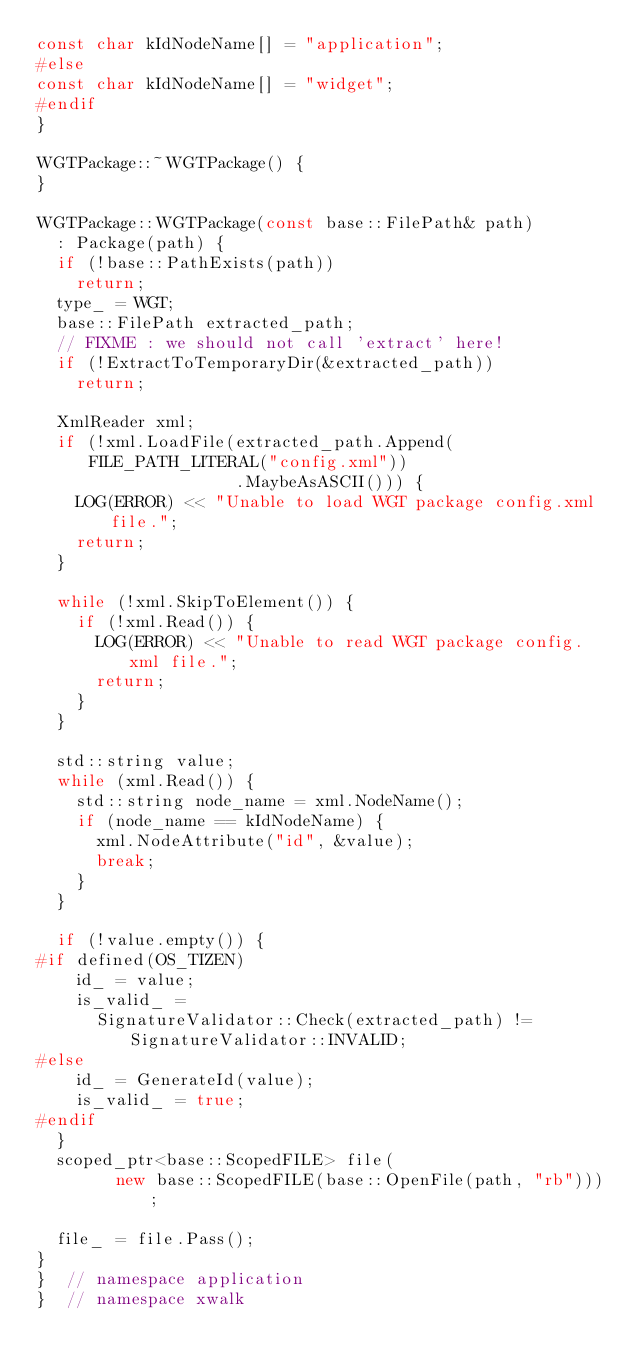Convert code to text. <code><loc_0><loc_0><loc_500><loc_500><_C++_>const char kIdNodeName[] = "application";
#else
const char kIdNodeName[] = "widget";
#endif
}

WGTPackage::~WGTPackage() {
}

WGTPackage::WGTPackage(const base::FilePath& path)
  : Package(path) {
  if (!base::PathExists(path))
    return;
  type_ = WGT;
  base::FilePath extracted_path;
  // FIXME : we should not call 'extract' here!
  if (!ExtractToTemporaryDir(&extracted_path))
    return;

  XmlReader xml;
  if (!xml.LoadFile(extracted_path.Append(FILE_PATH_LITERAL("config.xml"))
                    .MaybeAsASCII())) {
    LOG(ERROR) << "Unable to load WGT package config.xml file.";
    return;
  }

  while (!xml.SkipToElement()) {
    if (!xml.Read()) {
      LOG(ERROR) << "Unable to read WGT package config.xml file.";
      return;
    }
  }

  std::string value;
  while (xml.Read()) {
    std::string node_name = xml.NodeName();
    if (node_name == kIdNodeName) {
      xml.NodeAttribute("id", &value);
      break;
    }
  }

  if (!value.empty()) {
#if defined(OS_TIZEN)
    id_ = value;
    is_valid_ =
      SignatureValidator::Check(extracted_path) != SignatureValidator::INVALID;
#else
    id_ = GenerateId(value);
    is_valid_ = true;
#endif
  }
  scoped_ptr<base::ScopedFILE> file(
        new base::ScopedFILE(base::OpenFile(path, "rb")));

  file_ = file.Pass();
}
}  // namespace application
}  // namespace xwalk
</code> 